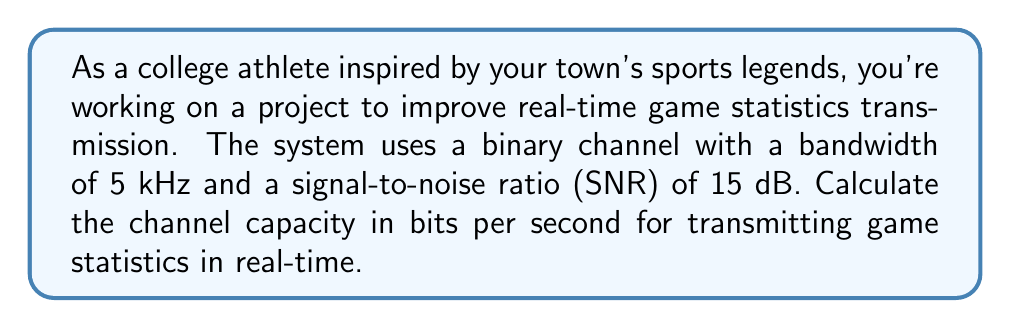Can you solve this math problem? To solve this problem, we'll use the Shannon-Hartley theorem, which gives the channel capacity for a noisy channel. The steps are as follows:

1) The Shannon-Hartley theorem states that the channel capacity $C$ is:

   $$C = B \log_2(1 + SNR)$$

   Where $B$ is the bandwidth in Hz, and SNR is the signal-to-noise ratio.

2) We're given:
   - Bandwidth $B = 5$ kHz $= 5000$ Hz
   - SNR $= 15$ dB

3) We need to convert the SNR from dB to a linear scale:
   
   $$SNR_{linear} = 10^{\frac{SNR_{dB}}{10}} = 10^{\frac{15}{10}} = 10^{1.5} \approx 31.6228$$

4) Now we can plug these values into the Shannon-Hartley formula:

   $$C = 5000 \log_2(1 + 31.6228)$$

5) Simplify:
   
   $$C = 5000 \log_2(32.6228)$$

6) Calculate:
   
   $$C \approx 5000 \cdot 5.0279 \approx 25139.5$$

Therefore, the channel capacity is approximately 25,139.5 bits per second.
Answer: The channel capacity for transmitting game statistics in real-time is approximately 25,140 bits per second. 